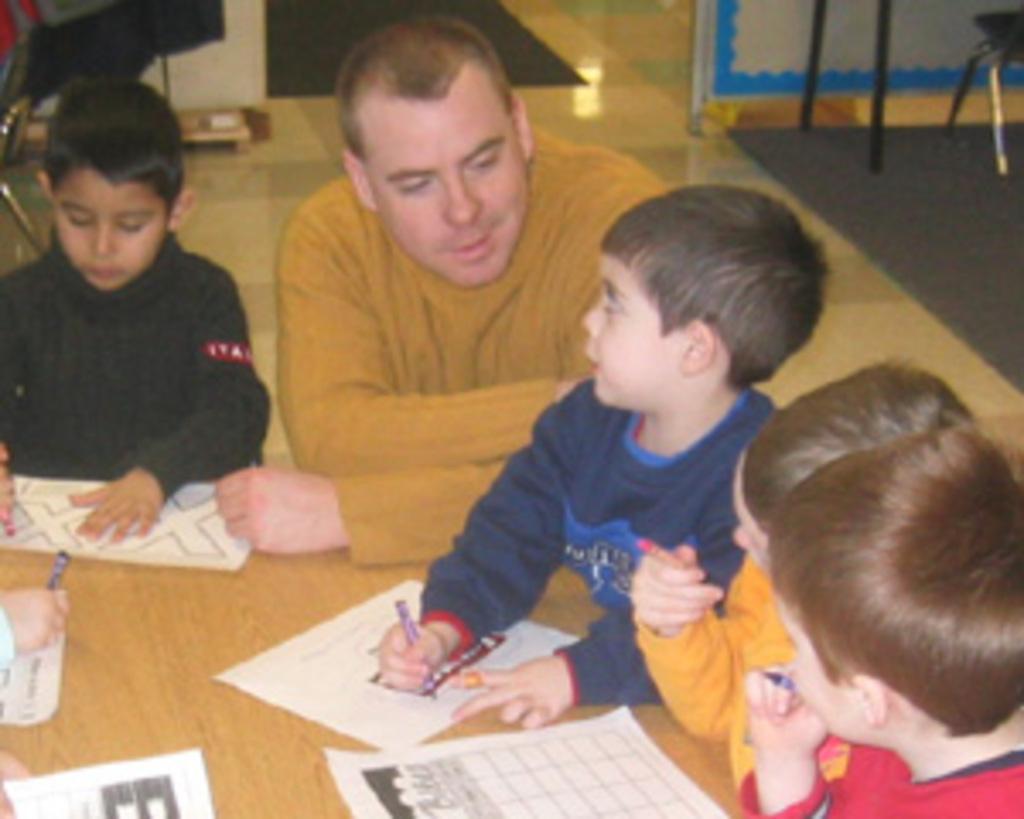Can you describe this image briefly? In this image there some persons sitting as we can see in middle of this image. There is one table at bottom left corner of this image , there is one chair at top left corner of this image and there are some objects at top right corner of this image. There are some papers kept on this table which is in white color. 